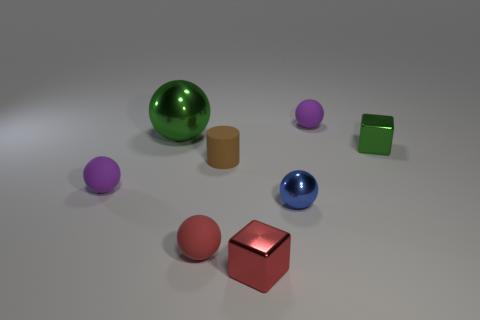Add 1 red metal balls. How many objects exist? 9 Subtract all cyan cubes. How many purple spheres are left? 2 Subtract all red matte spheres. How many spheres are left? 4 Subtract all green spheres. How many spheres are left? 4 Subtract all cubes. How many objects are left? 6 Add 1 small things. How many small things are left? 8 Add 2 small blue matte spheres. How many small blue matte spheres exist? 2 Subtract 0 yellow cubes. How many objects are left? 8 Subtract all cyan spheres. Subtract all cyan cubes. How many spheres are left? 5 Subtract all small green shiny balls. Subtract all purple rubber spheres. How many objects are left? 6 